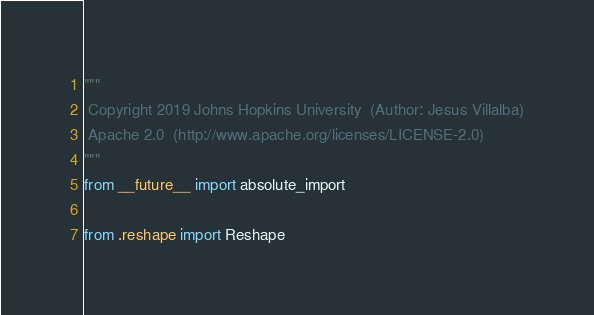Convert code to text. <code><loc_0><loc_0><loc_500><loc_500><_Python_>"""
 Copyright 2019 Johns Hopkins University  (Author: Jesus Villalba)
 Apache 2.0  (http://www.apache.org/licenses/LICENSE-2.0)
"""
from __future__ import absolute_import

from .reshape import Reshape

</code> 